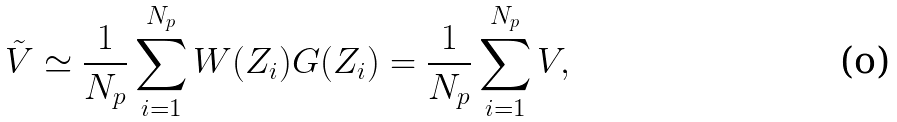Convert formula to latex. <formula><loc_0><loc_0><loc_500><loc_500>\tilde { V } \simeq \frac { 1 } { N _ { p } } \sum _ { i = 1 } ^ { N _ { p } } W ( Z _ { i } ) G ( Z _ { i } ) = \frac { 1 } { N _ { p } } \sum _ { i = 1 } ^ { N _ { p } } V ,</formula> 